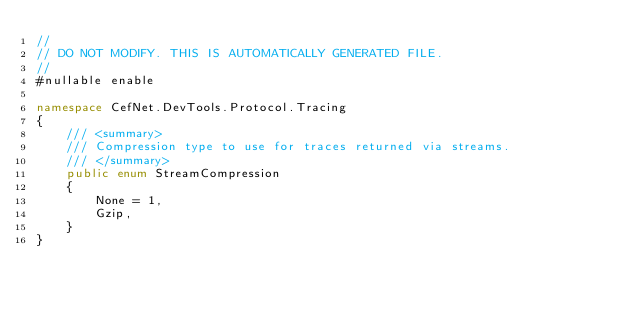<code> <loc_0><loc_0><loc_500><loc_500><_C#_>//
// DO NOT MODIFY. THIS IS AUTOMATICALLY GENERATED FILE.
//
#nullable enable

namespace CefNet.DevTools.Protocol.Tracing
{
    /// <summary>
    /// Compression type to use for traces returned via streams.
    /// </summary>
    public enum StreamCompression
    {
        None = 1,
        Gzip,
    }
}
</code> 